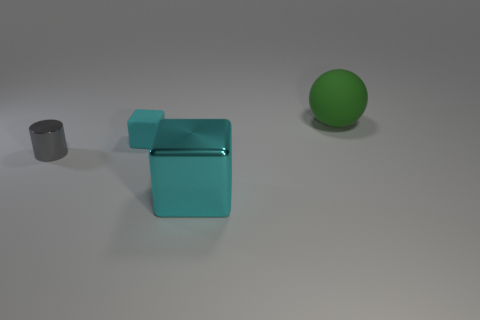Is the large cyan block made of the same material as the large thing that is behind the small matte block?
Give a very brief answer. No. What is the color of the object that is both to the right of the tiny cyan cube and in front of the green matte ball?
Ensure brevity in your answer.  Cyan. Is the size of the rubber sphere the same as the gray metal object?
Your response must be concise. No. Is there a tiny matte thing of the same color as the big metallic cube?
Ensure brevity in your answer.  Yes. The object that is the same size as the gray metal cylinder is what shape?
Your answer should be compact. Cube. There is a small rubber object that is the same color as the big cube; what shape is it?
Your answer should be very brief. Cube. What shape is the object that is the same material as the big cyan cube?
Give a very brief answer. Cylinder. Is there anything else that is the same color as the small shiny thing?
Offer a terse response. No. There is a matte thing to the right of the big thing in front of the small rubber cube; what number of big metal blocks are left of it?
Provide a succinct answer. 1. What number of gray objects are shiny things or big cylinders?
Your answer should be compact. 1. 